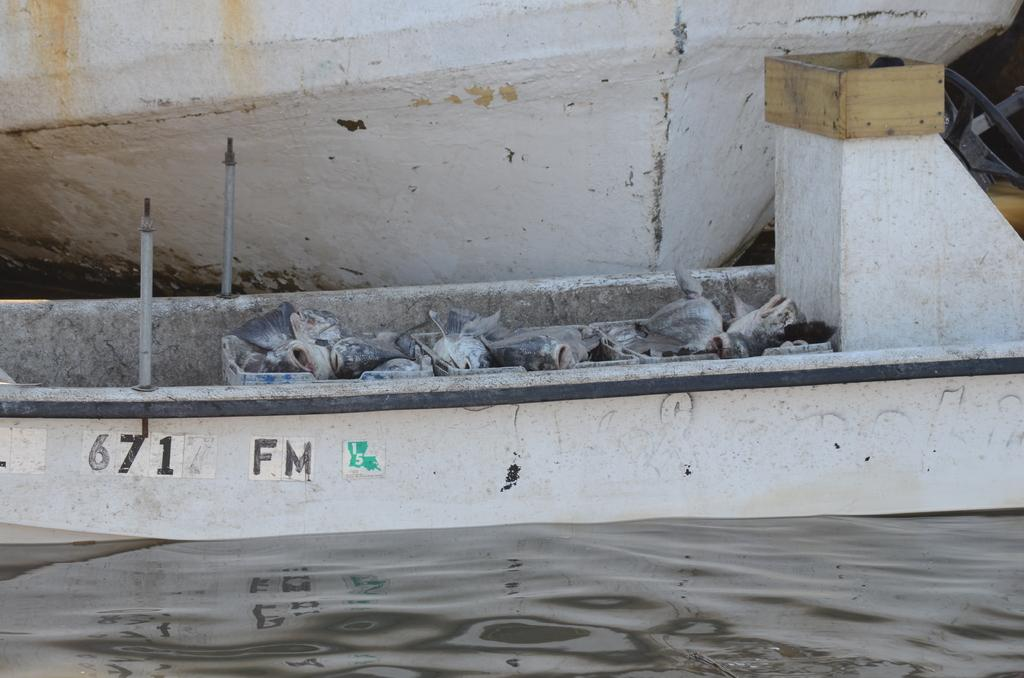What is the main subject of the image? The main subject of the image is a boat on the water. Are there any other objects or features visible in the image? Yes, there are plastic covers and a blue color box visible in the image. Can you describe the second boat in the image? There is another boat visible on top in the image. What type of quarter is being used to frame the boats in the image? There is no quarter or framing present in the image; it is a photograph of boats on the water. 